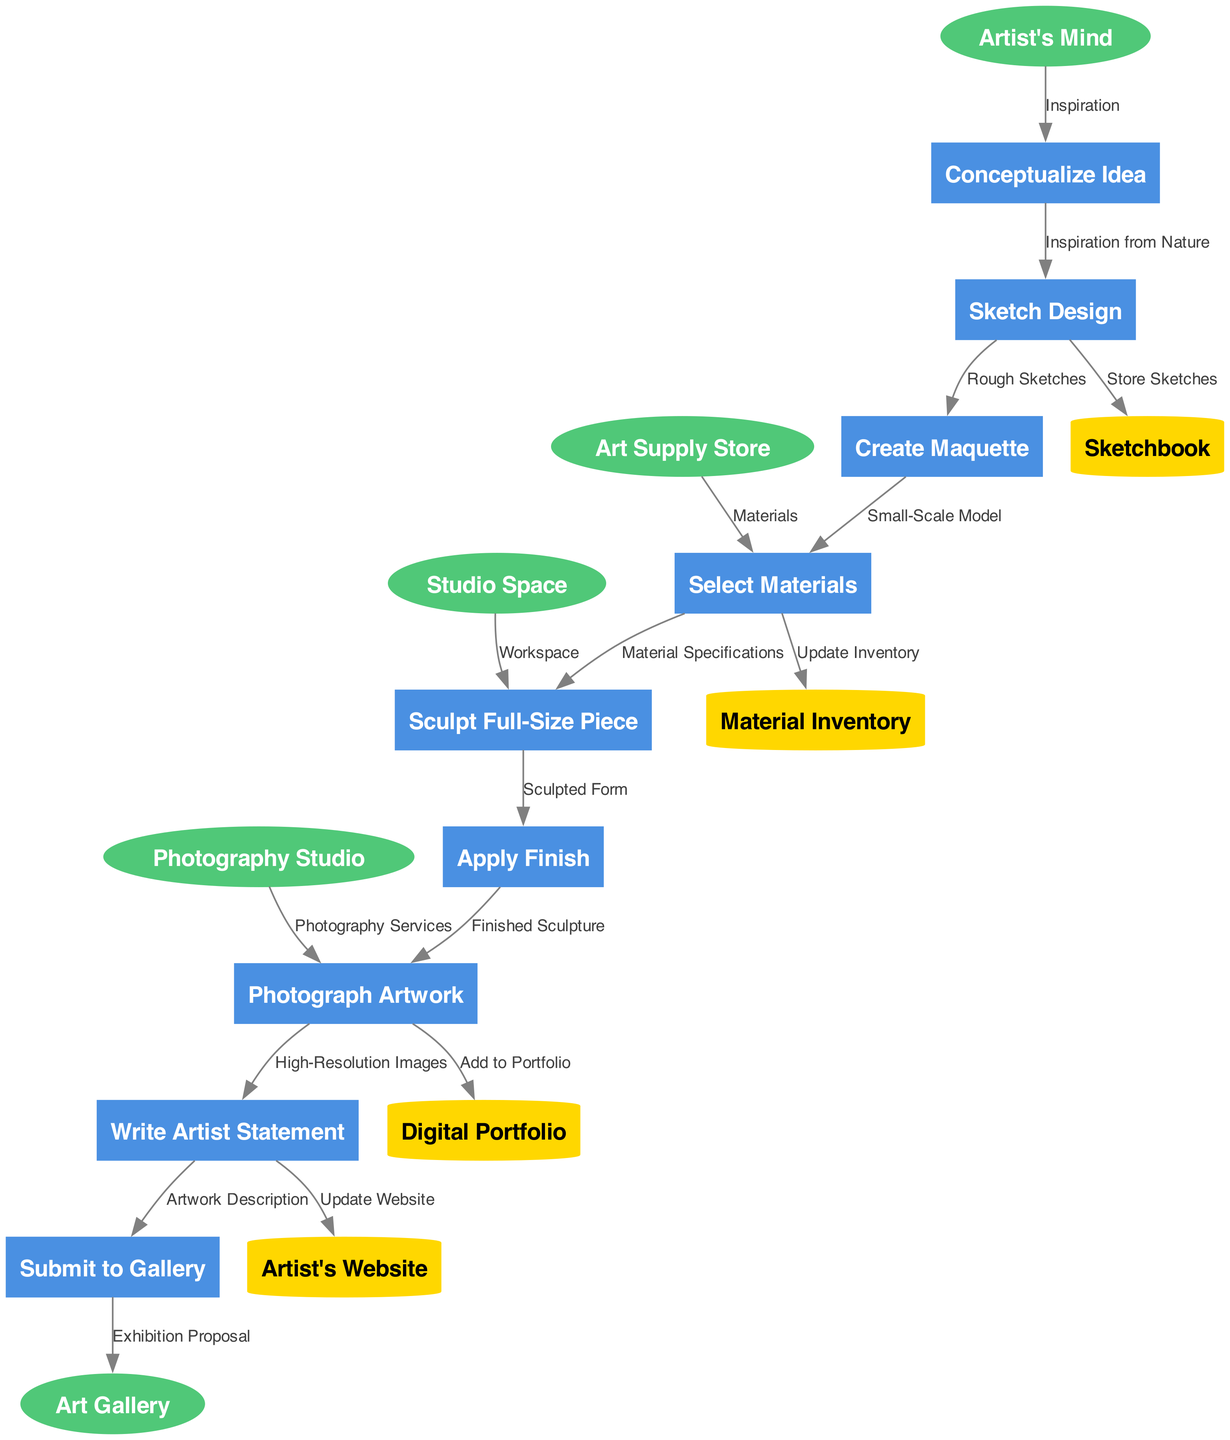What is the first process in the diagram? The first process listed in the diagram is "Conceptualize Idea," which is the starting point of the abstract sculpture creation process.
Answer: Conceptualize Idea How many processes are depicted in the diagram? By counting the processes listed, there are a total of nine processes in the diagram.
Answer: 9 What type of node represents the 'Studio Space'? 'Studio Space' is connected as an external entity, indicated by the ellipse shape used for external entities in the diagram.
Answer: External entity What data flow is associated with the transition from 'Sketch Design' to 'Create Maquette'? The labeled data flow between 'Sketch Design' and 'Create Maquette' is "Rough Sketches," which indicates what is being transferred in that step.
Answer: Rough Sketches Which external entity provides 'Materials'? The external entity that provides 'Materials' is the "Art Supply Store," as it connects directly to the 'Select Materials' process to supply needed materials.
Answer: Art Supply Store What is the role of 'High-Resolution Images' in the diagram? 'High-Resolution Images' is a data flow that is produced in the 'Photograph Artwork' process and is likely passed on to the next steps for documentation or exhibition purposes.
Answer: Data flow Identify the data store that holds 'Sketches'. The data store that holds 'Sketches' is called 'Sketchbook,' as indicated by the connection from 'Sketch Design' to this store in the diagram.
Answer: Sketchbook Which process comes immediately after 'Select Materials'? The process that immediately follows 'Select Materials' is 'Sculpt Full-Size Piece,' indicating the sequential flow in the sculpture creation process.
Answer: Sculpt Full-Size Piece What is the last process before the artwork is submitted to the gallery? The last process before artwork submission is 'Write Artist Statement,' as it comes just before 'Submit to Gallery' in the flow of processes.
Answer: Write Artist Statement How does the 'Photograph Artwork' process relate to the 'Digital Portfolio'? The 'Photograph Artwork' process feeds the 'High-Resolution Images' data flow into the 'Digital Portfolio' data store, indicating the storage of photographs for future showcase or documentation.
Answer: Digital Portfolio 